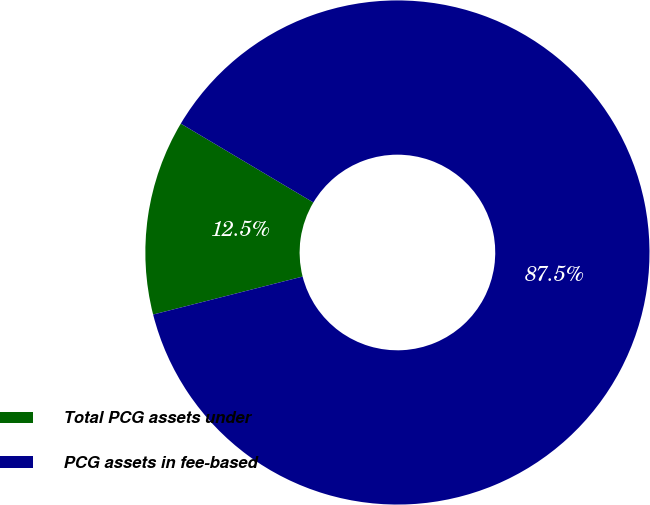<chart> <loc_0><loc_0><loc_500><loc_500><pie_chart><fcel>Total PCG assets under<fcel>PCG assets in fee-based<nl><fcel>12.5%<fcel>87.5%<nl></chart> 